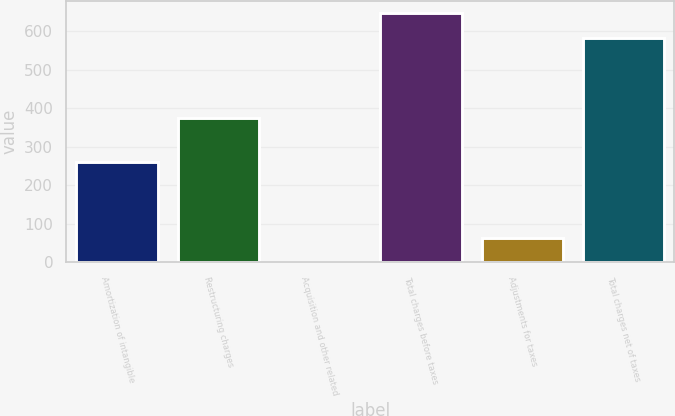Convert chart. <chart><loc_0><loc_0><loc_500><loc_500><bar_chart><fcel>Amortization of intangible<fcel>Restructuring charges<fcel>Acquisition and other related<fcel>Total charges before taxes<fcel>Adjustments for taxes<fcel>Total charges net of taxes<nl><fcel>260<fcel>375<fcel>1<fcel>647.5<fcel>64.5<fcel>584<nl></chart> 